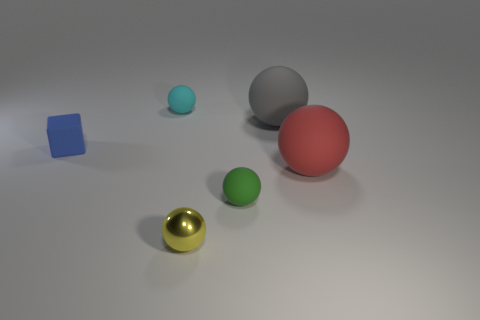The yellow thing is what shape?
Give a very brief answer. Sphere. How many cubes are either small blue matte objects or gray objects?
Offer a terse response. 1. Are there the same number of large gray balls in front of the red rubber ball and tiny blue objects that are behind the gray object?
Ensure brevity in your answer.  Yes. How many tiny things are right of the rubber ball on the left side of the tiny rubber thing on the right side of the yellow ball?
Keep it short and to the point. 2. Is the color of the block the same as the large ball in front of the gray object?
Offer a terse response. No. Are there more red matte things in front of the metal sphere than small yellow metal things?
Keep it short and to the point. No. How many things are either small matte objects behind the small blue thing or cyan balls behind the blue block?
Offer a very short reply. 1. There is a cyan object that is the same material as the small blue thing; what size is it?
Keep it short and to the point. Small. Is the shape of the small matte thing to the right of the tiny shiny sphere the same as  the tiny cyan thing?
Make the answer very short. Yes. What number of gray objects are either small matte things or large matte spheres?
Provide a succinct answer. 1. 